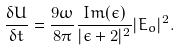<formula> <loc_0><loc_0><loc_500><loc_500>\frac { \delta U } { \delta t } = \frac { 9 \omega } { 8 \pi } \frac { I m ( \epsilon ) } { | \epsilon + 2 | ^ { 2 } } | E _ { o } | ^ { 2 } .</formula> 